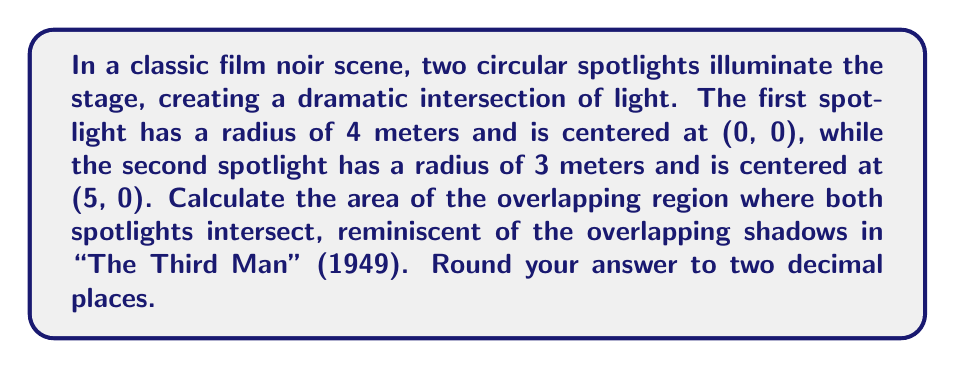What is the answer to this math problem? Let's approach this step-by-step:

1) First, we need to find the distance between the centers of the circles. We can use the distance formula:
   $$d = \sqrt{(x_2 - x_1)^2 + (y_2 - y_1)^2} = \sqrt{(5-0)^2 + (0-0)^2} = 5$$

2) Now, we can use the formula for the area of intersection of two circles:
   $$A = r_1^2 \arccos(\frac{d^2 + r_1^2 - r_2^2}{2dr_1}) + r_2^2 \arccos(\frac{d^2 + r_2^2 - r_1^2}{2dr_2}) - \frac{1}{2}\sqrt{(-d+r_1+r_2)(d+r_1-r_2)(d-r_1+r_2)(d+r_1+r_2)}$$

3) Let's substitute our values:
   $r_1 = 4$, $r_2 = 3$, $d = 5$

4) Calculating each part:
   $$4^2 \arccos(\frac{5^2 + 4^2 - 3^2}{2*5*4}) = 16 * 1.0472 = 16.7552$$
   $$3^2 \arccos(\frac{5^2 + 3^2 - 4^2}{2*5*3}) = 9 * 1.8235 = 16.4115$$
   $$\frac{1}{2}\sqrt{(-5+4+3)(5+4-3)(5-4+3)(5+4+3)} = 6$$

5) Putting it all together:
   $$A = 16.7552 + 16.4115 - 6 = 27.1667$$

6) Rounding to two decimal places:
   $$A \approx 27.17$$

[asy]
unitsize(20);
draw(circle((0,0),4));
draw(circle((5,0),3));
fill(circle((0,0),4),lightgray);
fill(circle((5,0),3),lightgray);
label("4m",(0,2),N);
label("3m",(5,1.5),N);
label("5m",(2.5,0),S);
[/asy]
Answer: 27.17 square meters 